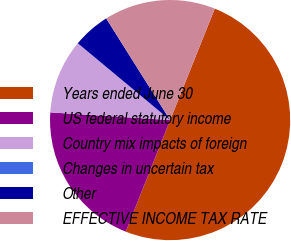<chart> <loc_0><loc_0><loc_500><loc_500><pie_chart><fcel>Years ended June 30<fcel>US federal statutory income<fcel>Country mix impacts of foreign<fcel>Changes in uncertain tax<fcel>Other<fcel>EFFECTIVE INCOME TAX RATE<nl><fcel>49.96%<fcel>20.0%<fcel>10.01%<fcel>0.02%<fcel>5.02%<fcel>15.0%<nl></chart> 